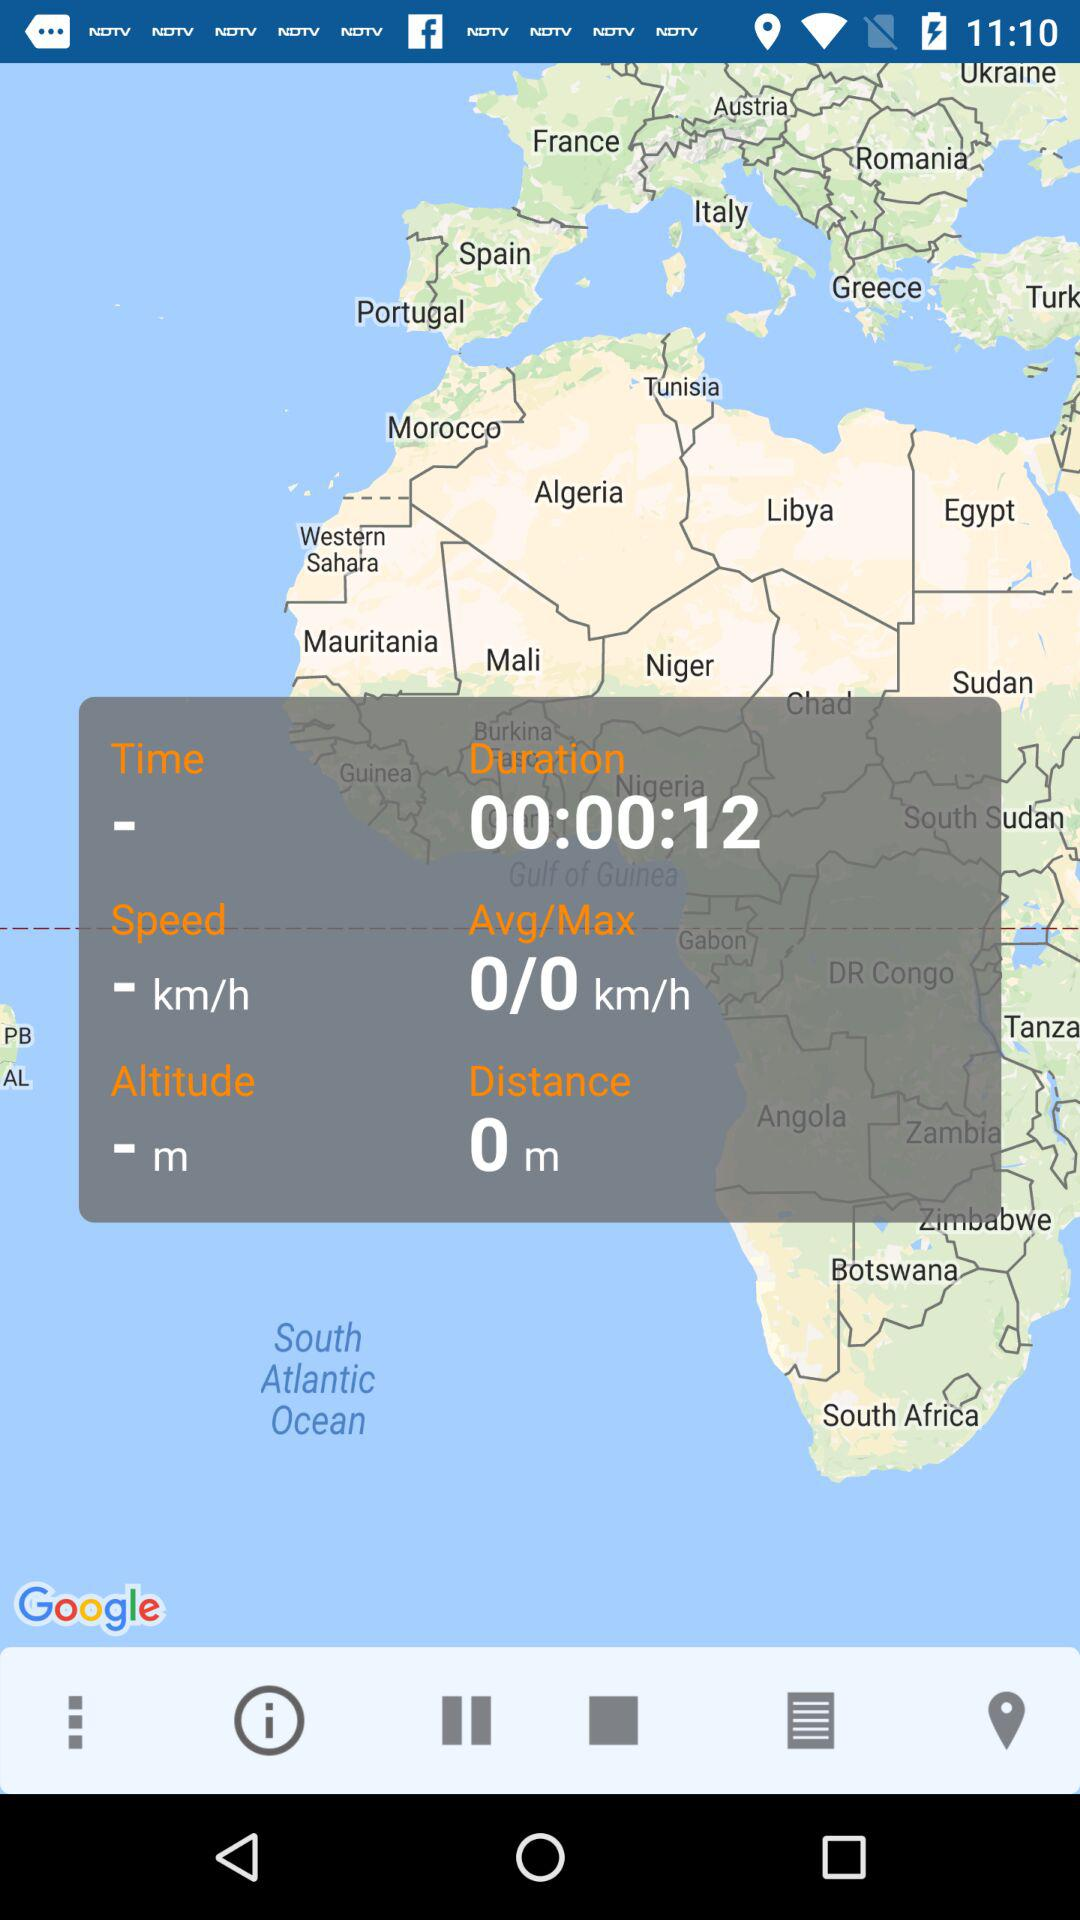What is the time duration? The time duration is 12 seconds. 